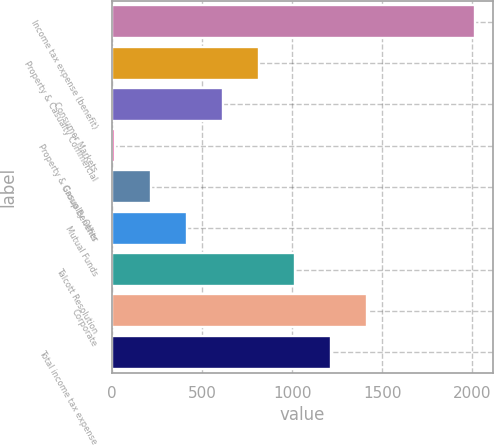Convert chart to OTSL. <chart><loc_0><loc_0><loc_500><loc_500><bar_chart><fcel>Income tax expense (benefit)<fcel>Property & Casualty Commercial<fcel>Consumer Markets<fcel>Property & Casualty Other<fcel>Group Benefits<fcel>Mutual Funds<fcel>Talcott Resolution<fcel>Corporate<fcel>Total income tax expense<nl><fcel>2012<fcel>813.2<fcel>613.4<fcel>14<fcel>213.8<fcel>413.6<fcel>1013<fcel>1412.6<fcel>1212.8<nl></chart> 